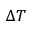<formula> <loc_0><loc_0><loc_500><loc_500>\Delta T</formula> 